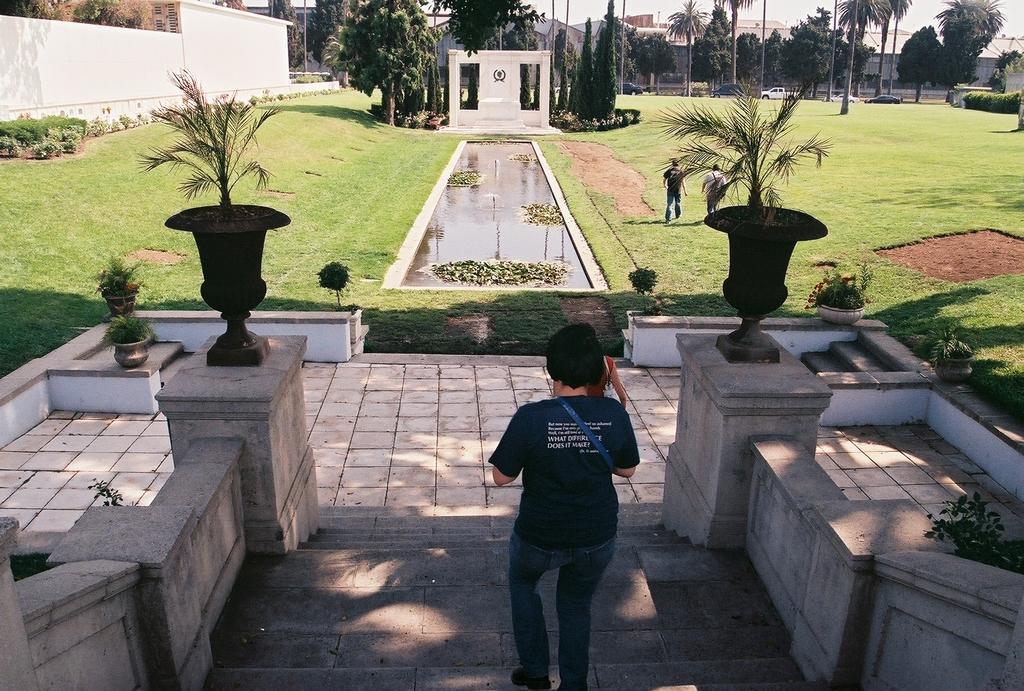Could you give a brief overview of what you see in this image? In this image we can see people and there are stairs. There are plants and trees. We can see a pond. In the background there are buildings, cars and sky. There is grass. 